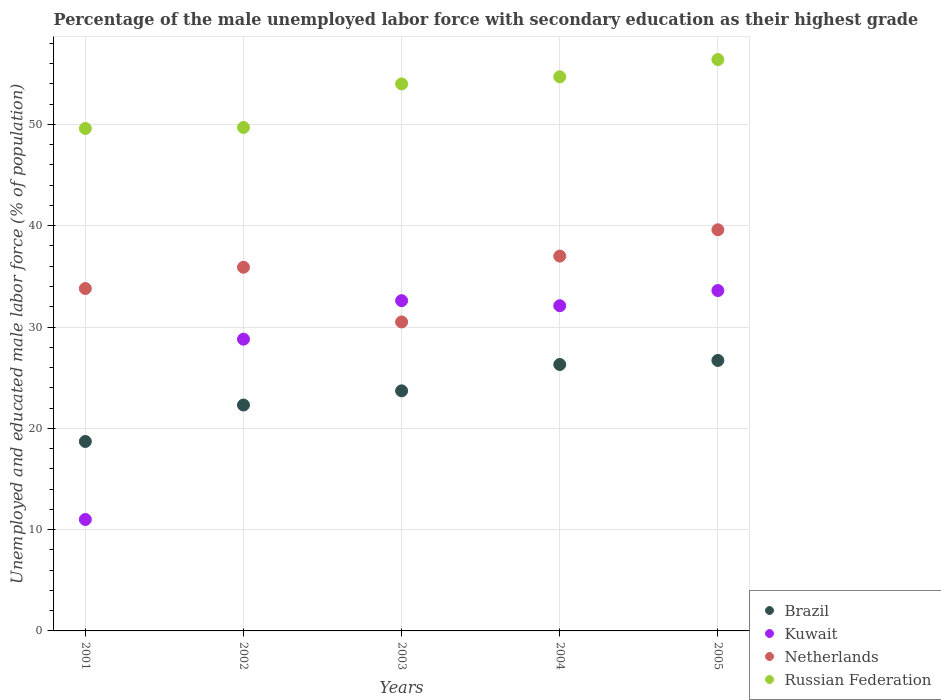Is the number of dotlines equal to the number of legend labels?
Provide a succinct answer. Yes. What is the percentage of the unemployed male labor force with secondary education in Russian Federation in 2004?
Provide a succinct answer. 54.7. Across all years, what is the maximum percentage of the unemployed male labor force with secondary education in Netherlands?
Ensure brevity in your answer.  39.6. Across all years, what is the minimum percentage of the unemployed male labor force with secondary education in Netherlands?
Your answer should be compact. 30.5. What is the total percentage of the unemployed male labor force with secondary education in Kuwait in the graph?
Offer a terse response. 138.1. What is the difference between the percentage of the unemployed male labor force with secondary education in Netherlands in 2001 and that in 2003?
Your answer should be compact. 3.3. What is the difference between the percentage of the unemployed male labor force with secondary education in Brazil in 2003 and the percentage of the unemployed male labor force with secondary education in Netherlands in 2005?
Provide a succinct answer. -15.9. What is the average percentage of the unemployed male labor force with secondary education in Russian Federation per year?
Your answer should be compact. 52.88. In the year 2001, what is the difference between the percentage of the unemployed male labor force with secondary education in Netherlands and percentage of the unemployed male labor force with secondary education in Brazil?
Your response must be concise. 15.1. What is the ratio of the percentage of the unemployed male labor force with secondary education in Brazil in 2003 to that in 2004?
Provide a short and direct response. 0.9. Is the percentage of the unemployed male labor force with secondary education in Kuwait in 2002 less than that in 2005?
Offer a very short reply. Yes. What is the difference between the highest and the second highest percentage of the unemployed male labor force with secondary education in Brazil?
Provide a short and direct response. 0.4. What is the difference between the highest and the lowest percentage of the unemployed male labor force with secondary education in Russian Federation?
Provide a succinct answer. 6.8. In how many years, is the percentage of the unemployed male labor force with secondary education in Netherlands greater than the average percentage of the unemployed male labor force with secondary education in Netherlands taken over all years?
Your answer should be very brief. 3. Is the sum of the percentage of the unemployed male labor force with secondary education in Russian Federation in 2001 and 2004 greater than the maximum percentage of the unemployed male labor force with secondary education in Netherlands across all years?
Your answer should be very brief. Yes. Does the percentage of the unemployed male labor force with secondary education in Kuwait monotonically increase over the years?
Offer a very short reply. No. Is the percentage of the unemployed male labor force with secondary education in Russian Federation strictly less than the percentage of the unemployed male labor force with secondary education in Netherlands over the years?
Provide a succinct answer. No. How many dotlines are there?
Keep it short and to the point. 4. Where does the legend appear in the graph?
Give a very brief answer. Bottom right. How many legend labels are there?
Give a very brief answer. 4. How are the legend labels stacked?
Your answer should be compact. Vertical. What is the title of the graph?
Give a very brief answer. Percentage of the male unemployed labor force with secondary education as their highest grade. What is the label or title of the X-axis?
Offer a very short reply. Years. What is the label or title of the Y-axis?
Keep it short and to the point. Unemployed and educated male labor force (% of population). What is the Unemployed and educated male labor force (% of population) in Brazil in 2001?
Keep it short and to the point. 18.7. What is the Unemployed and educated male labor force (% of population) of Kuwait in 2001?
Give a very brief answer. 11. What is the Unemployed and educated male labor force (% of population) in Netherlands in 2001?
Give a very brief answer. 33.8. What is the Unemployed and educated male labor force (% of population) in Russian Federation in 2001?
Your answer should be compact. 49.6. What is the Unemployed and educated male labor force (% of population) in Brazil in 2002?
Ensure brevity in your answer.  22.3. What is the Unemployed and educated male labor force (% of population) in Kuwait in 2002?
Provide a succinct answer. 28.8. What is the Unemployed and educated male labor force (% of population) of Netherlands in 2002?
Ensure brevity in your answer.  35.9. What is the Unemployed and educated male labor force (% of population) in Russian Federation in 2002?
Provide a short and direct response. 49.7. What is the Unemployed and educated male labor force (% of population) in Brazil in 2003?
Provide a short and direct response. 23.7. What is the Unemployed and educated male labor force (% of population) in Kuwait in 2003?
Give a very brief answer. 32.6. What is the Unemployed and educated male labor force (% of population) of Netherlands in 2003?
Make the answer very short. 30.5. What is the Unemployed and educated male labor force (% of population) of Russian Federation in 2003?
Provide a succinct answer. 54. What is the Unemployed and educated male labor force (% of population) of Brazil in 2004?
Provide a short and direct response. 26.3. What is the Unemployed and educated male labor force (% of population) of Kuwait in 2004?
Your answer should be compact. 32.1. What is the Unemployed and educated male labor force (% of population) in Russian Federation in 2004?
Your answer should be compact. 54.7. What is the Unemployed and educated male labor force (% of population) in Brazil in 2005?
Your response must be concise. 26.7. What is the Unemployed and educated male labor force (% of population) of Kuwait in 2005?
Your answer should be very brief. 33.6. What is the Unemployed and educated male labor force (% of population) in Netherlands in 2005?
Make the answer very short. 39.6. What is the Unemployed and educated male labor force (% of population) in Russian Federation in 2005?
Offer a terse response. 56.4. Across all years, what is the maximum Unemployed and educated male labor force (% of population) of Brazil?
Offer a very short reply. 26.7. Across all years, what is the maximum Unemployed and educated male labor force (% of population) of Kuwait?
Ensure brevity in your answer.  33.6. Across all years, what is the maximum Unemployed and educated male labor force (% of population) of Netherlands?
Give a very brief answer. 39.6. Across all years, what is the maximum Unemployed and educated male labor force (% of population) of Russian Federation?
Provide a succinct answer. 56.4. Across all years, what is the minimum Unemployed and educated male labor force (% of population) of Brazil?
Your answer should be very brief. 18.7. Across all years, what is the minimum Unemployed and educated male labor force (% of population) in Netherlands?
Give a very brief answer. 30.5. Across all years, what is the minimum Unemployed and educated male labor force (% of population) in Russian Federation?
Give a very brief answer. 49.6. What is the total Unemployed and educated male labor force (% of population) of Brazil in the graph?
Your response must be concise. 117.7. What is the total Unemployed and educated male labor force (% of population) in Kuwait in the graph?
Ensure brevity in your answer.  138.1. What is the total Unemployed and educated male labor force (% of population) of Netherlands in the graph?
Offer a very short reply. 176.8. What is the total Unemployed and educated male labor force (% of population) of Russian Federation in the graph?
Offer a terse response. 264.4. What is the difference between the Unemployed and educated male labor force (% of population) in Brazil in 2001 and that in 2002?
Make the answer very short. -3.6. What is the difference between the Unemployed and educated male labor force (% of population) in Kuwait in 2001 and that in 2002?
Provide a succinct answer. -17.8. What is the difference between the Unemployed and educated male labor force (% of population) of Russian Federation in 2001 and that in 2002?
Your response must be concise. -0.1. What is the difference between the Unemployed and educated male labor force (% of population) of Kuwait in 2001 and that in 2003?
Offer a very short reply. -21.6. What is the difference between the Unemployed and educated male labor force (% of population) in Netherlands in 2001 and that in 2003?
Your response must be concise. 3.3. What is the difference between the Unemployed and educated male labor force (% of population) in Kuwait in 2001 and that in 2004?
Your answer should be compact. -21.1. What is the difference between the Unemployed and educated male labor force (% of population) in Netherlands in 2001 and that in 2004?
Keep it short and to the point. -3.2. What is the difference between the Unemployed and educated male labor force (% of population) in Russian Federation in 2001 and that in 2004?
Provide a succinct answer. -5.1. What is the difference between the Unemployed and educated male labor force (% of population) in Brazil in 2001 and that in 2005?
Give a very brief answer. -8. What is the difference between the Unemployed and educated male labor force (% of population) of Kuwait in 2001 and that in 2005?
Your answer should be very brief. -22.6. What is the difference between the Unemployed and educated male labor force (% of population) of Netherlands in 2001 and that in 2005?
Your response must be concise. -5.8. What is the difference between the Unemployed and educated male labor force (% of population) of Brazil in 2002 and that in 2003?
Offer a terse response. -1.4. What is the difference between the Unemployed and educated male labor force (% of population) of Netherlands in 2002 and that in 2003?
Your answer should be compact. 5.4. What is the difference between the Unemployed and educated male labor force (% of population) of Russian Federation in 2002 and that in 2003?
Provide a succinct answer. -4.3. What is the difference between the Unemployed and educated male labor force (% of population) in Russian Federation in 2002 and that in 2004?
Offer a terse response. -5. What is the difference between the Unemployed and educated male labor force (% of population) in Brazil in 2002 and that in 2005?
Offer a terse response. -4.4. What is the difference between the Unemployed and educated male labor force (% of population) in Kuwait in 2002 and that in 2005?
Give a very brief answer. -4.8. What is the difference between the Unemployed and educated male labor force (% of population) of Netherlands in 2002 and that in 2005?
Your answer should be compact. -3.7. What is the difference between the Unemployed and educated male labor force (% of population) of Russian Federation in 2002 and that in 2005?
Ensure brevity in your answer.  -6.7. What is the difference between the Unemployed and educated male labor force (% of population) of Brazil in 2003 and that in 2005?
Offer a very short reply. -3. What is the difference between the Unemployed and educated male labor force (% of population) of Netherlands in 2003 and that in 2005?
Provide a short and direct response. -9.1. What is the difference between the Unemployed and educated male labor force (% of population) in Russian Federation in 2003 and that in 2005?
Offer a terse response. -2.4. What is the difference between the Unemployed and educated male labor force (% of population) in Netherlands in 2004 and that in 2005?
Your answer should be compact. -2.6. What is the difference between the Unemployed and educated male labor force (% of population) in Russian Federation in 2004 and that in 2005?
Your response must be concise. -1.7. What is the difference between the Unemployed and educated male labor force (% of population) in Brazil in 2001 and the Unemployed and educated male labor force (% of population) in Kuwait in 2002?
Make the answer very short. -10.1. What is the difference between the Unemployed and educated male labor force (% of population) of Brazil in 2001 and the Unemployed and educated male labor force (% of population) of Netherlands in 2002?
Provide a short and direct response. -17.2. What is the difference between the Unemployed and educated male labor force (% of population) in Brazil in 2001 and the Unemployed and educated male labor force (% of population) in Russian Federation in 2002?
Give a very brief answer. -31. What is the difference between the Unemployed and educated male labor force (% of population) in Kuwait in 2001 and the Unemployed and educated male labor force (% of population) in Netherlands in 2002?
Provide a short and direct response. -24.9. What is the difference between the Unemployed and educated male labor force (% of population) in Kuwait in 2001 and the Unemployed and educated male labor force (% of population) in Russian Federation in 2002?
Make the answer very short. -38.7. What is the difference between the Unemployed and educated male labor force (% of population) in Netherlands in 2001 and the Unemployed and educated male labor force (% of population) in Russian Federation in 2002?
Provide a succinct answer. -15.9. What is the difference between the Unemployed and educated male labor force (% of population) of Brazil in 2001 and the Unemployed and educated male labor force (% of population) of Russian Federation in 2003?
Keep it short and to the point. -35.3. What is the difference between the Unemployed and educated male labor force (% of population) in Kuwait in 2001 and the Unemployed and educated male labor force (% of population) in Netherlands in 2003?
Keep it short and to the point. -19.5. What is the difference between the Unemployed and educated male labor force (% of population) of Kuwait in 2001 and the Unemployed and educated male labor force (% of population) of Russian Federation in 2003?
Your answer should be compact. -43. What is the difference between the Unemployed and educated male labor force (% of population) of Netherlands in 2001 and the Unemployed and educated male labor force (% of population) of Russian Federation in 2003?
Your answer should be very brief. -20.2. What is the difference between the Unemployed and educated male labor force (% of population) in Brazil in 2001 and the Unemployed and educated male labor force (% of population) in Kuwait in 2004?
Your answer should be very brief. -13.4. What is the difference between the Unemployed and educated male labor force (% of population) of Brazil in 2001 and the Unemployed and educated male labor force (% of population) of Netherlands in 2004?
Provide a succinct answer. -18.3. What is the difference between the Unemployed and educated male labor force (% of population) in Brazil in 2001 and the Unemployed and educated male labor force (% of population) in Russian Federation in 2004?
Give a very brief answer. -36. What is the difference between the Unemployed and educated male labor force (% of population) in Kuwait in 2001 and the Unemployed and educated male labor force (% of population) in Netherlands in 2004?
Ensure brevity in your answer.  -26. What is the difference between the Unemployed and educated male labor force (% of population) of Kuwait in 2001 and the Unemployed and educated male labor force (% of population) of Russian Federation in 2004?
Give a very brief answer. -43.7. What is the difference between the Unemployed and educated male labor force (% of population) in Netherlands in 2001 and the Unemployed and educated male labor force (% of population) in Russian Federation in 2004?
Your answer should be very brief. -20.9. What is the difference between the Unemployed and educated male labor force (% of population) of Brazil in 2001 and the Unemployed and educated male labor force (% of population) of Kuwait in 2005?
Your answer should be compact. -14.9. What is the difference between the Unemployed and educated male labor force (% of population) in Brazil in 2001 and the Unemployed and educated male labor force (% of population) in Netherlands in 2005?
Give a very brief answer. -20.9. What is the difference between the Unemployed and educated male labor force (% of population) in Brazil in 2001 and the Unemployed and educated male labor force (% of population) in Russian Federation in 2005?
Make the answer very short. -37.7. What is the difference between the Unemployed and educated male labor force (% of population) in Kuwait in 2001 and the Unemployed and educated male labor force (% of population) in Netherlands in 2005?
Your answer should be compact. -28.6. What is the difference between the Unemployed and educated male labor force (% of population) of Kuwait in 2001 and the Unemployed and educated male labor force (% of population) of Russian Federation in 2005?
Provide a short and direct response. -45.4. What is the difference between the Unemployed and educated male labor force (% of population) in Netherlands in 2001 and the Unemployed and educated male labor force (% of population) in Russian Federation in 2005?
Your response must be concise. -22.6. What is the difference between the Unemployed and educated male labor force (% of population) in Brazil in 2002 and the Unemployed and educated male labor force (% of population) in Netherlands in 2003?
Offer a terse response. -8.2. What is the difference between the Unemployed and educated male labor force (% of population) in Brazil in 2002 and the Unemployed and educated male labor force (% of population) in Russian Federation in 2003?
Ensure brevity in your answer.  -31.7. What is the difference between the Unemployed and educated male labor force (% of population) in Kuwait in 2002 and the Unemployed and educated male labor force (% of population) in Netherlands in 2003?
Your answer should be compact. -1.7. What is the difference between the Unemployed and educated male labor force (% of population) of Kuwait in 2002 and the Unemployed and educated male labor force (% of population) of Russian Federation in 2003?
Offer a very short reply. -25.2. What is the difference between the Unemployed and educated male labor force (% of population) of Netherlands in 2002 and the Unemployed and educated male labor force (% of population) of Russian Federation in 2003?
Give a very brief answer. -18.1. What is the difference between the Unemployed and educated male labor force (% of population) in Brazil in 2002 and the Unemployed and educated male labor force (% of population) in Kuwait in 2004?
Provide a succinct answer. -9.8. What is the difference between the Unemployed and educated male labor force (% of population) of Brazil in 2002 and the Unemployed and educated male labor force (% of population) of Netherlands in 2004?
Your response must be concise. -14.7. What is the difference between the Unemployed and educated male labor force (% of population) of Brazil in 2002 and the Unemployed and educated male labor force (% of population) of Russian Federation in 2004?
Make the answer very short. -32.4. What is the difference between the Unemployed and educated male labor force (% of population) in Kuwait in 2002 and the Unemployed and educated male labor force (% of population) in Netherlands in 2004?
Offer a very short reply. -8.2. What is the difference between the Unemployed and educated male labor force (% of population) in Kuwait in 2002 and the Unemployed and educated male labor force (% of population) in Russian Federation in 2004?
Provide a short and direct response. -25.9. What is the difference between the Unemployed and educated male labor force (% of population) in Netherlands in 2002 and the Unemployed and educated male labor force (% of population) in Russian Federation in 2004?
Your response must be concise. -18.8. What is the difference between the Unemployed and educated male labor force (% of population) in Brazil in 2002 and the Unemployed and educated male labor force (% of population) in Kuwait in 2005?
Give a very brief answer. -11.3. What is the difference between the Unemployed and educated male labor force (% of population) in Brazil in 2002 and the Unemployed and educated male labor force (% of population) in Netherlands in 2005?
Keep it short and to the point. -17.3. What is the difference between the Unemployed and educated male labor force (% of population) in Brazil in 2002 and the Unemployed and educated male labor force (% of population) in Russian Federation in 2005?
Provide a succinct answer. -34.1. What is the difference between the Unemployed and educated male labor force (% of population) of Kuwait in 2002 and the Unemployed and educated male labor force (% of population) of Russian Federation in 2005?
Your answer should be compact. -27.6. What is the difference between the Unemployed and educated male labor force (% of population) in Netherlands in 2002 and the Unemployed and educated male labor force (% of population) in Russian Federation in 2005?
Make the answer very short. -20.5. What is the difference between the Unemployed and educated male labor force (% of population) of Brazil in 2003 and the Unemployed and educated male labor force (% of population) of Kuwait in 2004?
Keep it short and to the point. -8.4. What is the difference between the Unemployed and educated male labor force (% of population) of Brazil in 2003 and the Unemployed and educated male labor force (% of population) of Russian Federation in 2004?
Offer a terse response. -31. What is the difference between the Unemployed and educated male labor force (% of population) of Kuwait in 2003 and the Unemployed and educated male labor force (% of population) of Russian Federation in 2004?
Provide a succinct answer. -22.1. What is the difference between the Unemployed and educated male labor force (% of population) of Netherlands in 2003 and the Unemployed and educated male labor force (% of population) of Russian Federation in 2004?
Your answer should be very brief. -24.2. What is the difference between the Unemployed and educated male labor force (% of population) of Brazil in 2003 and the Unemployed and educated male labor force (% of population) of Kuwait in 2005?
Keep it short and to the point. -9.9. What is the difference between the Unemployed and educated male labor force (% of population) in Brazil in 2003 and the Unemployed and educated male labor force (% of population) in Netherlands in 2005?
Offer a terse response. -15.9. What is the difference between the Unemployed and educated male labor force (% of population) of Brazil in 2003 and the Unemployed and educated male labor force (% of population) of Russian Federation in 2005?
Give a very brief answer. -32.7. What is the difference between the Unemployed and educated male labor force (% of population) of Kuwait in 2003 and the Unemployed and educated male labor force (% of population) of Russian Federation in 2005?
Provide a short and direct response. -23.8. What is the difference between the Unemployed and educated male labor force (% of population) in Netherlands in 2003 and the Unemployed and educated male labor force (% of population) in Russian Federation in 2005?
Your answer should be very brief. -25.9. What is the difference between the Unemployed and educated male labor force (% of population) of Brazil in 2004 and the Unemployed and educated male labor force (% of population) of Kuwait in 2005?
Make the answer very short. -7.3. What is the difference between the Unemployed and educated male labor force (% of population) in Brazil in 2004 and the Unemployed and educated male labor force (% of population) in Netherlands in 2005?
Provide a succinct answer. -13.3. What is the difference between the Unemployed and educated male labor force (% of population) in Brazil in 2004 and the Unemployed and educated male labor force (% of population) in Russian Federation in 2005?
Offer a terse response. -30.1. What is the difference between the Unemployed and educated male labor force (% of population) of Kuwait in 2004 and the Unemployed and educated male labor force (% of population) of Netherlands in 2005?
Keep it short and to the point. -7.5. What is the difference between the Unemployed and educated male labor force (% of population) in Kuwait in 2004 and the Unemployed and educated male labor force (% of population) in Russian Federation in 2005?
Keep it short and to the point. -24.3. What is the difference between the Unemployed and educated male labor force (% of population) of Netherlands in 2004 and the Unemployed and educated male labor force (% of population) of Russian Federation in 2005?
Make the answer very short. -19.4. What is the average Unemployed and educated male labor force (% of population) of Brazil per year?
Ensure brevity in your answer.  23.54. What is the average Unemployed and educated male labor force (% of population) in Kuwait per year?
Provide a succinct answer. 27.62. What is the average Unemployed and educated male labor force (% of population) of Netherlands per year?
Your answer should be compact. 35.36. What is the average Unemployed and educated male labor force (% of population) in Russian Federation per year?
Give a very brief answer. 52.88. In the year 2001, what is the difference between the Unemployed and educated male labor force (% of population) in Brazil and Unemployed and educated male labor force (% of population) in Kuwait?
Keep it short and to the point. 7.7. In the year 2001, what is the difference between the Unemployed and educated male labor force (% of population) of Brazil and Unemployed and educated male labor force (% of population) of Netherlands?
Your answer should be very brief. -15.1. In the year 2001, what is the difference between the Unemployed and educated male labor force (% of population) in Brazil and Unemployed and educated male labor force (% of population) in Russian Federation?
Offer a very short reply. -30.9. In the year 2001, what is the difference between the Unemployed and educated male labor force (% of population) of Kuwait and Unemployed and educated male labor force (% of population) of Netherlands?
Give a very brief answer. -22.8. In the year 2001, what is the difference between the Unemployed and educated male labor force (% of population) of Kuwait and Unemployed and educated male labor force (% of population) of Russian Federation?
Your answer should be compact. -38.6. In the year 2001, what is the difference between the Unemployed and educated male labor force (% of population) in Netherlands and Unemployed and educated male labor force (% of population) in Russian Federation?
Give a very brief answer. -15.8. In the year 2002, what is the difference between the Unemployed and educated male labor force (% of population) of Brazil and Unemployed and educated male labor force (% of population) of Kuwait?
Offer a terse response. -6.5. In the year 2002, what is the difference between the Unemployed and educated male labor force (% of population) in Brazil and Unemployed and educated male labor force (% of population) in Russian Federation?
Make the answer very short. -27.4. In the year 2002, what is the difference between the Unemployed and educated male labor force (% of population) in Kuwait and Unemployed and educated male labor force (% of population) in Netherlands?
Give a very brief answer. -7.1. In the year 2002, what is the difference between the Unemployed and educated male labor force (% of population) of Kuwait and Unemployed and educated male labor force (% of population) of Russian Federation?
Ensure brevity in your answer.  -20.9. In the year 2003, what is the difference between the Unemployed and educated male labor force (% of population) in Brazil and Unemployed and educated male labor force (% of population) in Kuwait?
Your answer should be very brief. -8.9. In the year 2003, what is the difference between the Unemployed and educated male labor force (% of population) of Brazil and Unemployed and educated male labor force (% of population) of Russian Federation?
Ensure brevity in your answer.  -30.3. In the year 2003, what is the difference between the Unemployed and educated male labor force (% of population) of Kuwait and Unemployed and educated male labor force (% of population) of Netherlands?
Make the answer very short. 2.1. In the year 2003, what is the difference between the Unemployed and educated male labor force (% of population) of Kuwait and Unemployed and educated male labor force (% of population) of Russian Federation?
Provide a short and direct response. -21.4. In the year 2003, what is the difference between the Unemployed and educated male labor force (% of population) of Netherlands and Unemployed and educated male labor force (% of population) of Russian Federation?
Your answer should be very brief. -23.5. In the year 2004, what is the difference between the Unemployed and educated male labor force (% of population) in Brazil and Unemployed and educated male labor force (% of population) in Netherlands?
Your answer should be very brief. -10.7. In the year 2004, what is the difference between the Unemployed and educated male labor force (% of population) in Brazil and Unemployed and educated male labor force (% of population) in Russian Federation?
Provide a succinct answer. -28.4. In the year 2004, what is the difference between the Unemployed and educated male labor force (% of population) in Kuwait and Unemployed and educated male labor force (% of population) in Russian Federation?
Give a very brief answer. -22.6. In the year 2004, what is the difference between the Unemployed and educated male labor force (% of population) of Netherlands and Unemployed and educated male labor force (% of population) of Russian Federation?
Ensure brevity in your answer.  -17.7. In the year 2005, what is the difference between the Unemployed and educated male labor force (% of population) of Brazil and Unemployed and educated male labor force (% of population) of Russian Federation?
Provide a short and direct response. -29.7. In the year 2005, what is the difference between the Unemployed and educated male labor force (% of population) in Kuwait and Unemployed and educated male labor force (% of population) in Russian Federation?
Offer a very short reply. -22.8. In the year 2005, what is the difference between the Unemployed and educated male labor force (% of population) in Netherlands and Unemployed and educated male labor force (% of population) in Russian Federation?
Provide a short and direct response. -16.8. What is the ratio of the Unemployed and educated male labor force (% of population) of Brazil in 2001 to that in 2002?
Offer a terse response. 0.84. What is the ratio of the Unemployed and educated male labor force (% of population) of Kuwait in 2001 to that in 2002?
Offer a very short reply. 0.38. What is the ratio of the Unemployed and educated male labor force (% of population) of Netherlands in 2001 to that in 2002?
Provide a succinct answer. 0.94. What is the ratio of the Unemployed and educated male labor force (% of population) in Brazil in 2001 to that in 2003?
Keep it short and to the point. 0.79. What is the ratio of the Unemployed and educated male labor force (% of population) in Kuwait in 2001 to that in 2003?
Offer a terse response. 0.34. What is the ratio of the Unemployed and educated male labor force (% of population) of Netherlands in 2001 to that in 2003?
Your answer should be compact. 1.11. What is the ratio of the Unemployed and educated male labor force (% of population) of Russian Federation in 2001 to that in 2003?
Ensure brevity in your answer.  0.92. What is the ratio of the Unemployed and educated male labor force (% of population) of Brazil in 2001 to that in 2004?
Provide a succinct answer. 0.71. What is the ratio of the Unemployed and educated male labor force (% of population) in Kuwait in 2001 to that in 2004?
Provide a succinct answer. 0.34. What is the ratio of the Unemployed and educated male labor force (% of population) in Netherlands in 2001 to that in 2004?
Make the answer very short. 0.91. What is the ratio of the Unemployed and educated male labor force (% of population) of Russian Federation in 2001 to that in 2004?
Your response must be concise. 0.91. What is the ratio of the Unemployed and educated male labor force (% of population) in Brazil in 2001 to that in 2005?
Offer a very short reply. 0.7. What is the ratio of the Unemployed and educated male labor force (% of population) of Kuwait in 2001 to that in 2005?
Give a very brief answer. 0.33. What is the ratio of the Unemployed and educated male labor force (% of population) of Netherlands in 2001 to that in 2005?
Provide a short and direct response. 0.85. What is the ratio of the Unemployed and educated male labor force (% of population) in Russian Federation in 2001 to that in 2005?
Offer a very short reply. 0.88. What is the ratio of the Unemployed and educated male labor force (% of population) in Brazil in 2002 to that in 2003?
Your response must be concise. 0.94. What is the ratio of the Unemployed and educated male labor force (% of population) in Kuwait in 2002 to that in 2003?
Keep it short and to the point. 0.88. What is the ratio of the Unemployed and educated male labor force (% of population) in Netherlands in 2002 to that in 2003?
Give a very brief answer. 1.18. What is the ratio of the Unemployed and educated male labor force (% of population) in Russian Federation in 2002 to that in 2003?
Give a very brief answer. 0.92. What is the ratio of the Unemployed and educated male labor force (% of population) in Brazil in 2002 to that in 2004?
Offer a terse response. 0.85. What is the ratio of the Unemployed and educated male labor force (% of population) in Kuwait in 2002 to that in 2004?
Provide a short and direct response. 0.9. What is the ratio of the Unemployed and educated male labor force (% of population) in Netherlands in 2002 to that in 2004?
Ensure brevity in your answer.  0.97. What is the ratio of the Unemployed and educated male labor force (% of population) in Russian Federation in 2002 to that in 2004?
Give a very brief answer. 0.91. What is the ratio of the Unemployed and educated male labor force (% of population) of Brazil in 2002 to that in 2005?
Your answer should be very brief. 0.84. What is the ratio of the Unemployed and educated male labor force (% of population) in Kuwait in 2002 to that in 2005?
Give a very brief answer. 0.86. What is the ratio of the Unemployed and educated male labor force (% of population) of Netherlands in 2002 to that in 2005?
Your answer should be very brief. 0.91. What is the ratio of the Unemployed and educated male labor force (% of population) of Russian Federation in 2002 to that in 2005?
Your response must be concise. 0.88. What is the ratio of the Unemployed and educated male labor force (% of population) in Brazil in 2003 to that in 2004?
Offer a terse response. 0.9. What is the ratio of the Unemployed and educated male labor force (% of population) of Kuwait in 2003 to that in 2004?
Offer a terse response. 1.02. What is the ratio of the Unemployed and educated male labor force (% of population) in Netherlands in 2003 to that in 2004?
Ensure brevity in your answer.  0.82. What is the ratio of the Unemployed and educated male labor force (% of population) in Russian Federation in 2003 to that in 2004?
Your answer should be very brief. 0.99. What is the ratio of the Unemployed and educated male labor force (% of population) in Brazil in 2003 to that in 2005?
Ensure brevity in your answer.  0.89. What is the ratio of the Unemployed and educated male labor force (% of population) of Kuwait in 2003 to that in 2005?
Ensure brevity in your answer.  0.97. What is the ratio of the Unemployed and educated male labor force (% of population) in Netherlands in 2003 to that in 2005?
Provide a short and direct response. 0.77. What is the ratio of the Unemployed and educated male labor force (% of population) in Russian Federation in 2003 to that in 2005?
Offer a terse response. 0.96. What is the ratio of the Unemployed and educated male labor force (% of population) in Brazil in 2004 to that in 2005?
Make the answer very short. 0.98. What is the ratio of the Unemployed and educated male labor force (% of population) in Kuwait in 2004 to that in 2005?
Provide a succinct answer. 0.96. What is the ratio of the Unemployed and educated male labor force (% of population) in Netherlands in 2004 to that in 2005?
Your answer should be very brief. 0.93. What is the ratio of the Unemployed and educated male labor force (% of population) in Russian Federation in 2004 to that in 2005?
Make the answer very short. 0.97. What is the difference between the highest and the lowest Unemployed and educated male labor force (% of population) in Kuwait?
Offer a very short reply. 22.6. What is the difference between the highest and the lowest Unemployed and educated male labor force (% of population) of Netherlands?
Provide a succinct answer. 9.1. 